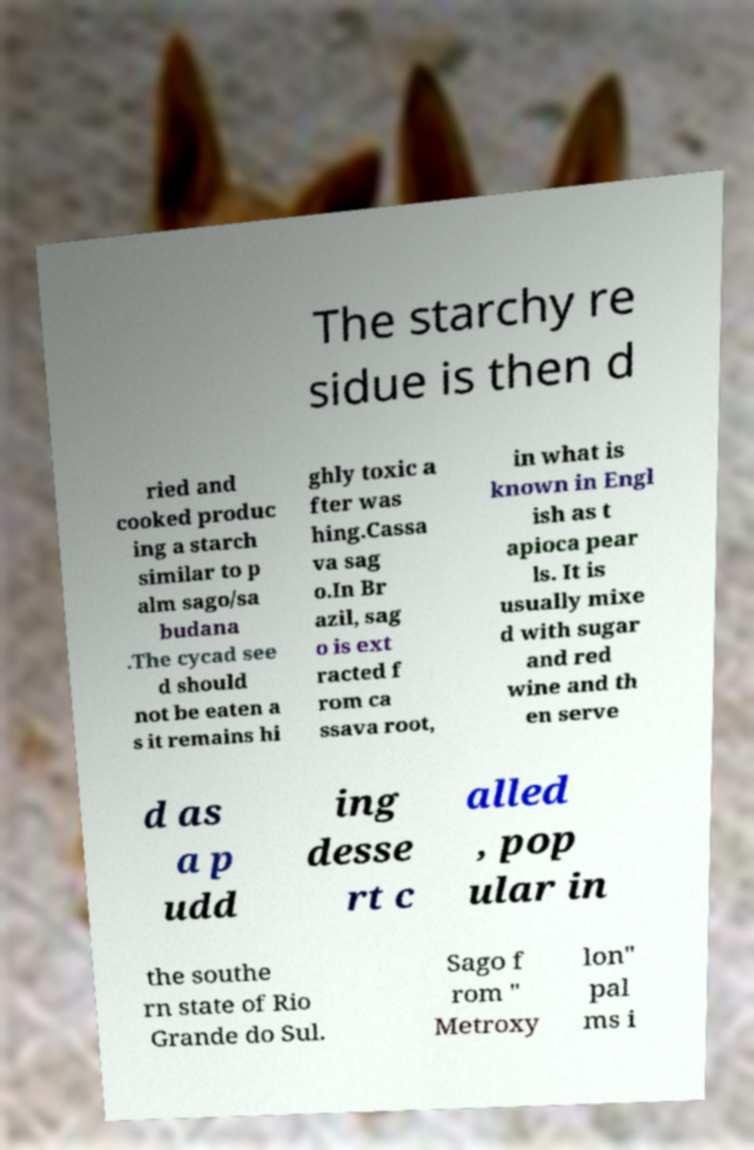Please identify and transcribe the text found in this image. The starchy re sidue is then d ried and cooked produc ing a starch similar to p alm sago/sa budana .The cycad see d should not be eaten a s it remains hi ghly toxic a fter was hing.Cassa va sag o.In Br azil, sag o is ext racted f rom ca ssava root, in what is known in Engl ish as t apioca pear ls. It is usually mixe d with sugar and red wine and th en serve d as a p udd ing desse rt c alled , pop ular in the southe rn state of Rio Grande do Sul. Sago f rom " Metroxy lon" pal ms i 